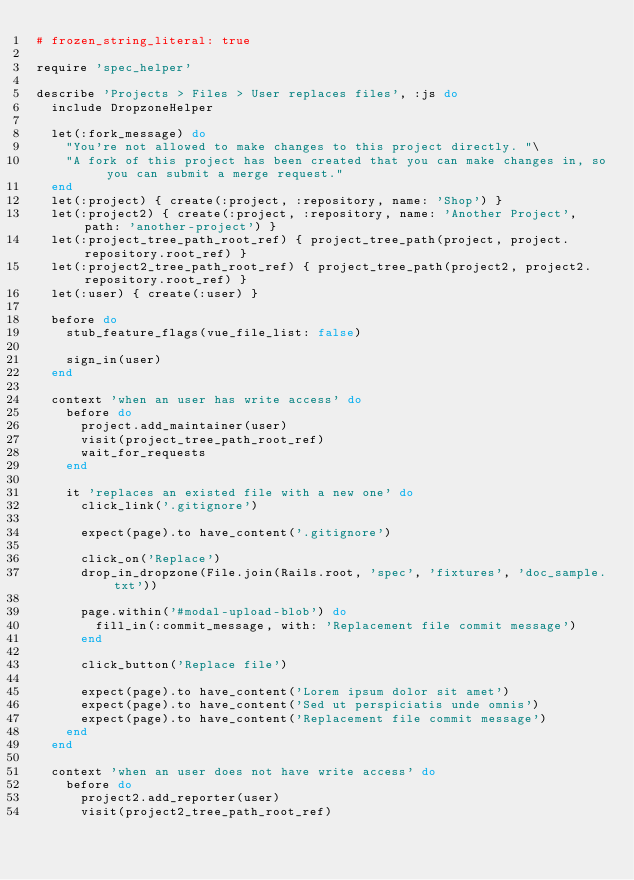<code> <loc_0><loc_0><loc_500><loc_500><_Ruby_># frozen_string_literal: true

require 'spec_helper'

describe 'Projects > Files > User replaces files', :js do
  include DropzoneHelper

  let(:fork_message) do
    "You're not allowed to make changes to this project directly. "\
    "A fork of this project has been created that you can make changes in, so you can submit a merge request."
  end
  let(:project) { create(:project, :repository, name: 'Shop') }
  let(:project2) { create(:project, :repository, name: 'Another Project', path: 'another-project') }
  let(:project_tree_path_root_ref) { project_tree_path(project, project.repository.root_ref) }
  let(:project2_tree_path_root_ref) { project_tree_path(project2, project2.repository.root_ref) }
  let(:user) { create(:user) }

  before do
    stub_feature_flags(vue_file_list: false)

    sign_in(user)
  end

  context 'when an user has write access' do
    before do
      project.add_maintainer(user)
      visit(project_tree_path_root_ref)
      wait_for_requests
    end

    it 'replaces an existed file with a new one' do
      click_link('.gitignore')

      expect(page).to have_content('.gitignore')

      click_on('Replace')
      drop_in_dropzone(File.join(Rails.root, 'spec', 'fixtures', 'doc_sample.txt'))

      page.within('#modal-upload-blob') do
        fill_in(:commit_message, with: 'Replacement file commit message')
      end

      click_button('Replace file')

      expect(page).to have_content('Lorem ipsum dolor sit amet')
      expect(page).to have_content('Sed ut perspiciatis unde omnis')
      expect(page).to have_content('Replacement file commit message')
    end
  end

  context 'when an user does not have write access' do
    before do
      project2.add_reporter(user)
      visit(project2_tree_path_root_ref)</code> 